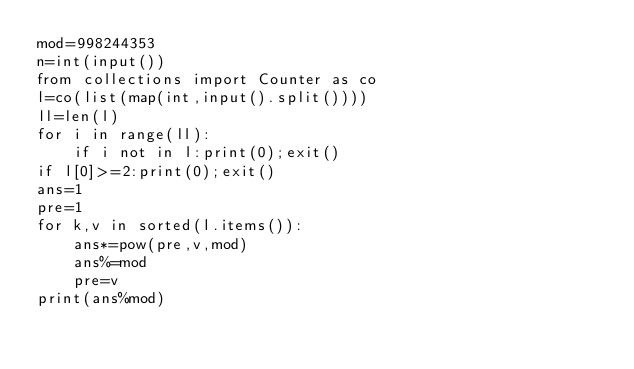<code> <loc_0><loc_0><loc_500><loc_500><_Python_>mod=998244353
n=int(input())
from collections import Counter as co
l=co(list(map(int,input().split())))
ll=len(l)
for i in range(ll):
    if i not in l:print(0);exit()
if l[0]>=2:print(0);exit()
ans=1
pre=1
for k,v in sorted(l.items()):
    ans*=pow(pre,v,mod)
    ans%=mod
    pre=v
print(ans%mod)</code> 